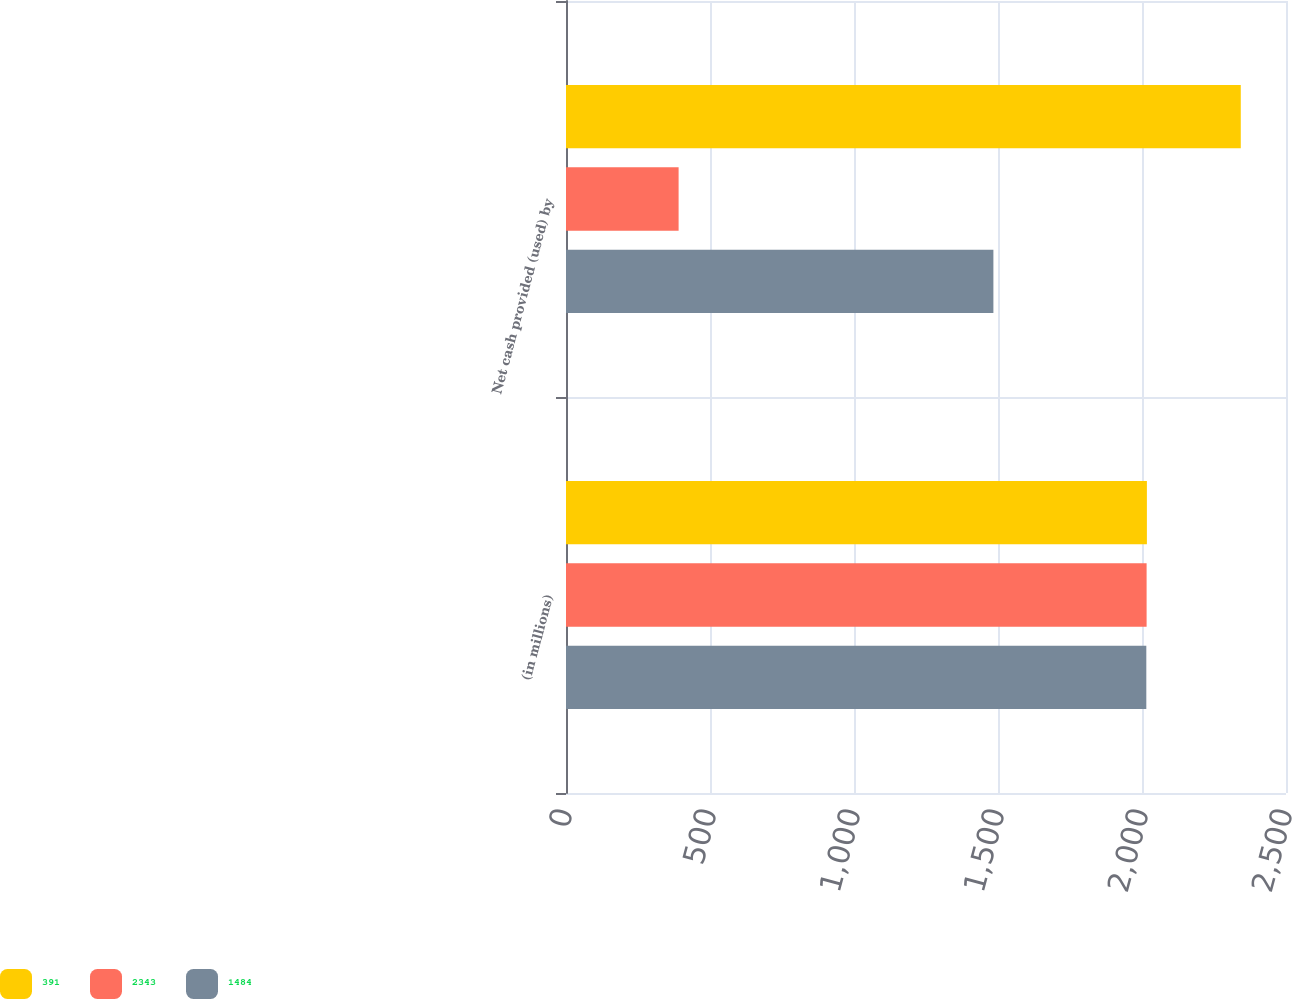Convert chart to OTSL. <chart><loc_0><loc_0><loc_500><loc_500><stacked_bar_chart><ecel><fcel>(in millions)<fcel>Net cash provided (used) by<nl><fcel>391<fcel>2017<fcel>2343<nl><fcel>2343<fcel>2016<fcel>391<nl><fcel>1484<fcel>2015<fcel>1484<nl></chart> 